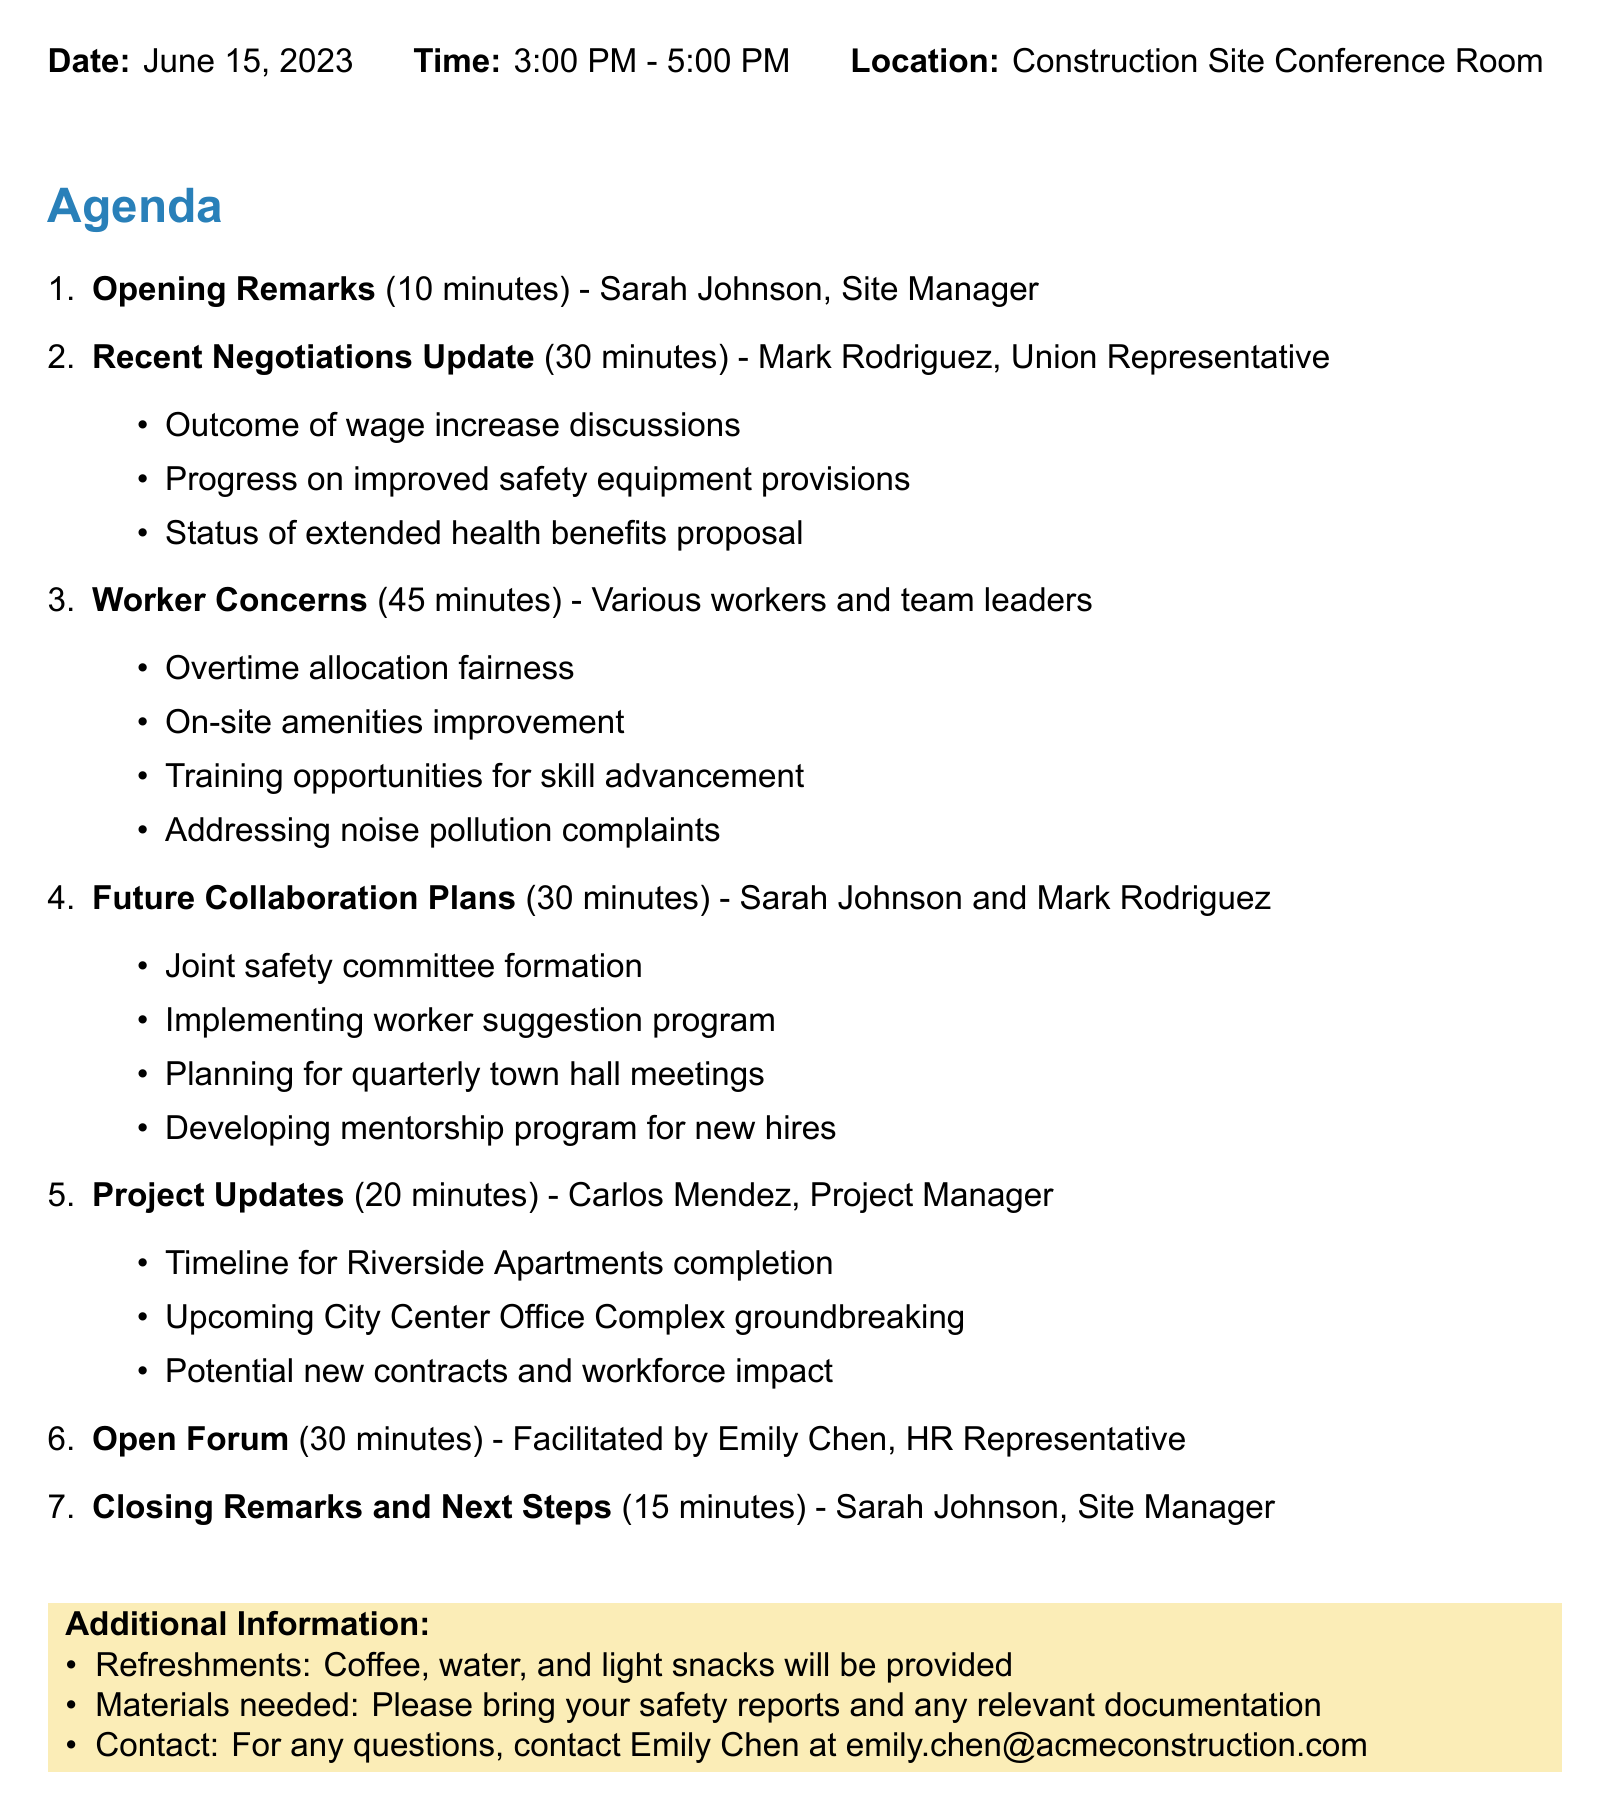What is the date of the meeting? The date of the meeting is explicitly stated in the header section of the document.
Answer: June 15, 2023 Who is the speaker for the opening remarks? The speaker for the opening remarks is listed under the first agenda item.
Answer: Sarah Johnson What is the duration of the worker concerns discussion? The duration for the worker concerns discussion is specified in the agenda.
Answer: 45 minutes What are the subtopics under recent negotiations update? The subtopics related to recent negotiations are detailed in the agenda under the respective item.
Answer: Outcome of wage increase discussions, Progress on improved safety equipment provisions, Status of extended health benefits proposal How many items are there in total on the agenda? The total number of items on the agenda can be counted from the enumeration in the document.
Answer: 7 Who is facilitating the open forum? The facilitator for the open forum is listed in the corresponding agenda item.
Answer: Emily Chen What is provided as additional information at the end of the document? The additional information includes details on refreshments, materials needed, and contact information.
Answer: Refreshments, materials needed, contact person 